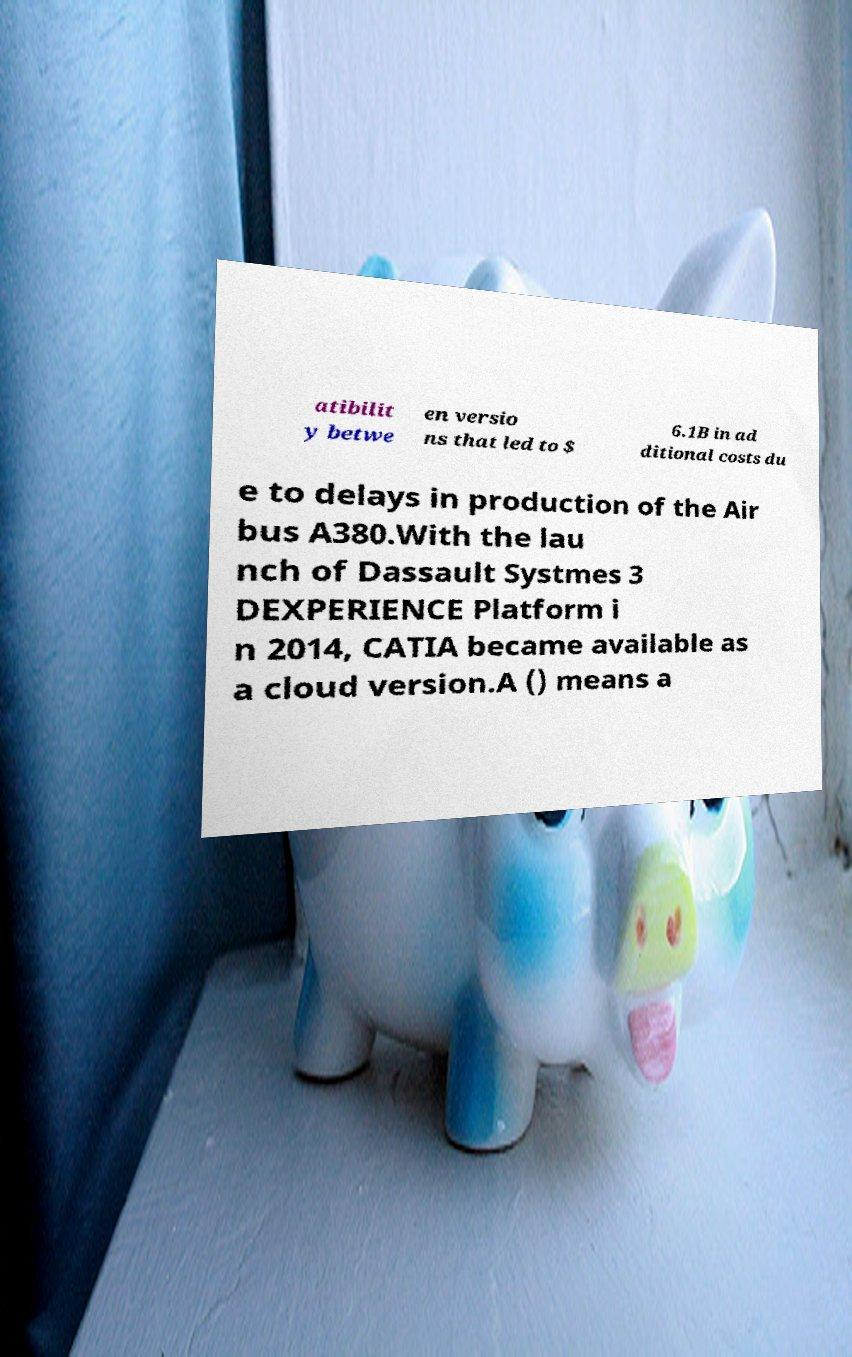I need the written content from this picture converted into text. Can you do that? atibilit y betwe en versio ns that led to $ 6.1B in ad ditional costs du e to delays in production of the Air bus A380.With the lau nch of Dassault Systmes 3 DEXPERIENCE Platform i n 2014, CATIA became available as a cloud version.A () means a 